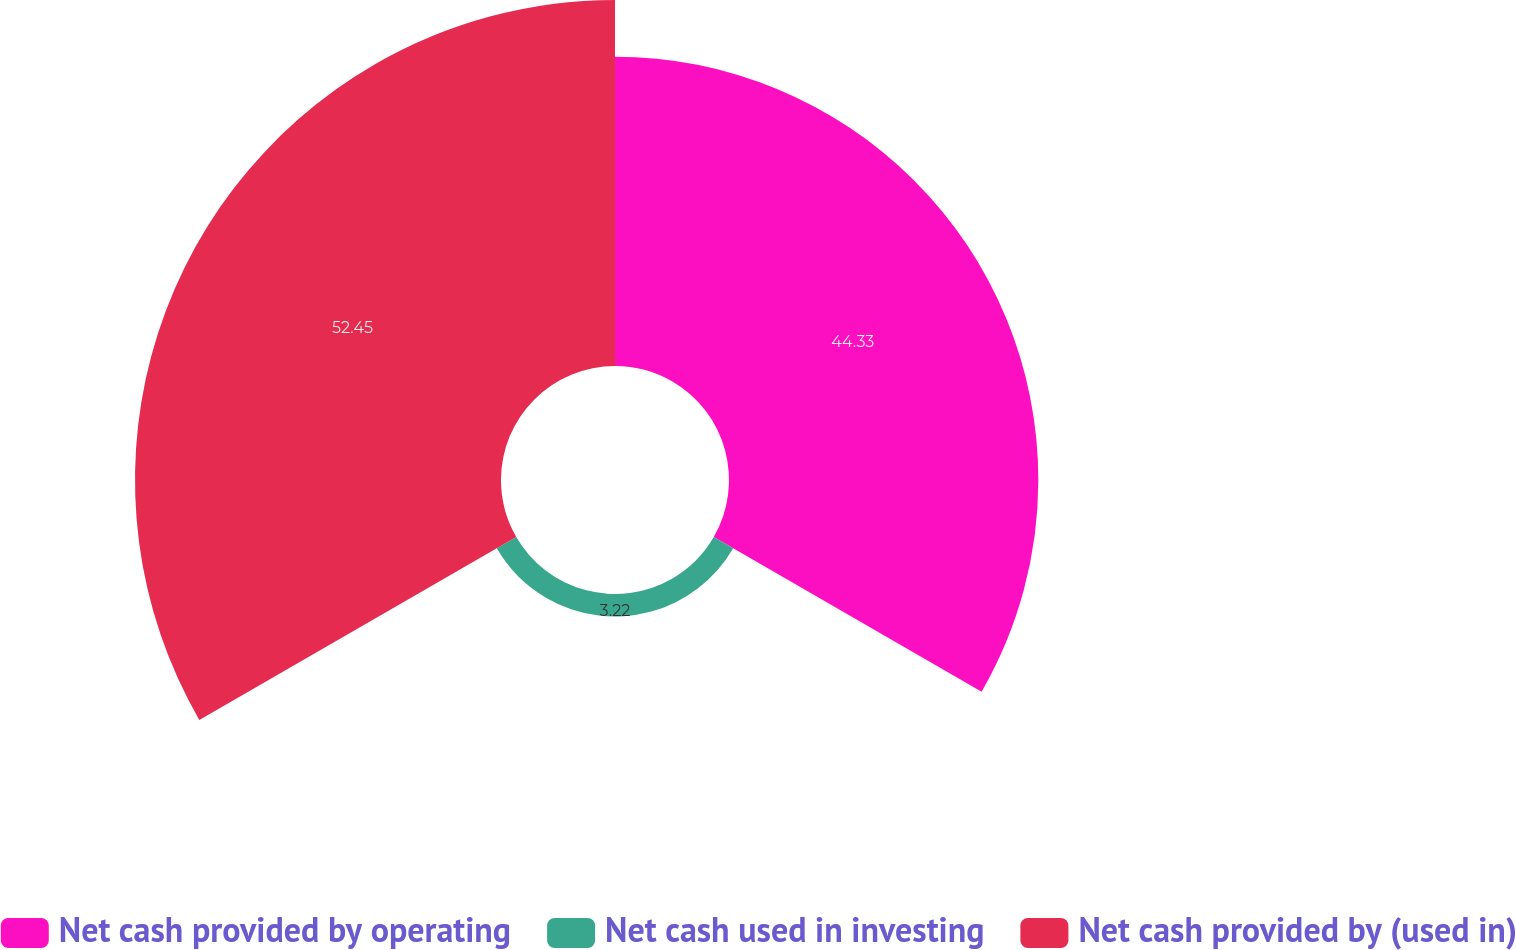Convert chart to OTSL. <chart><loc_0><loc_0><loc_500><loc_500><pie_chart><fcel>Net cash provided by operating<fcel>Net cash used in investing<fcel>Net cash provided by (used in)<nl><fcel>44.33%<fcel>3.22%<fcel>52.45%<nl></chart> 